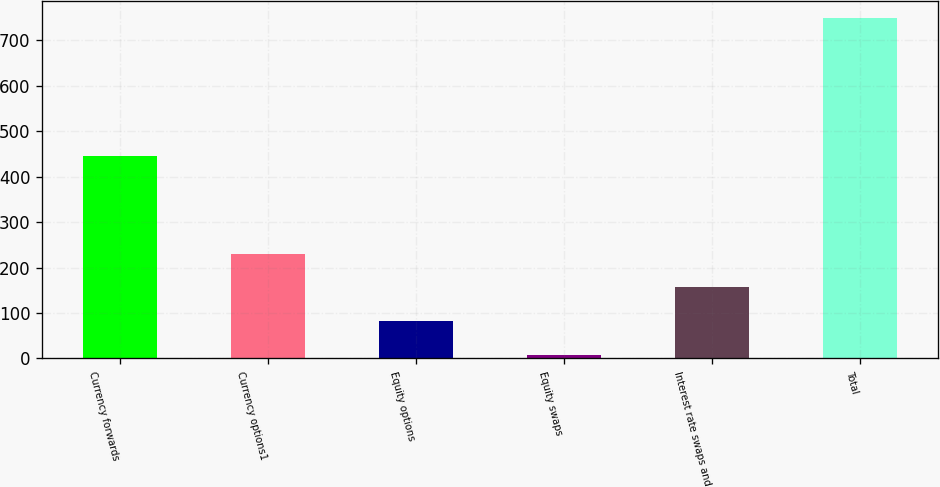<chart> <loc_0><loc_0><loc_500><loc_500><bar_chart><fcel>Currency forwards<fcel>Currency options1<fcel>Equity options<fcel>Equity swaps<fcel>Interest rate swaps and<fcel>Total<nl><fcel>446<fcel>230.6<fcel>82.2<fcel>8<fcel>156.4<fcel>750<nl></chart> 